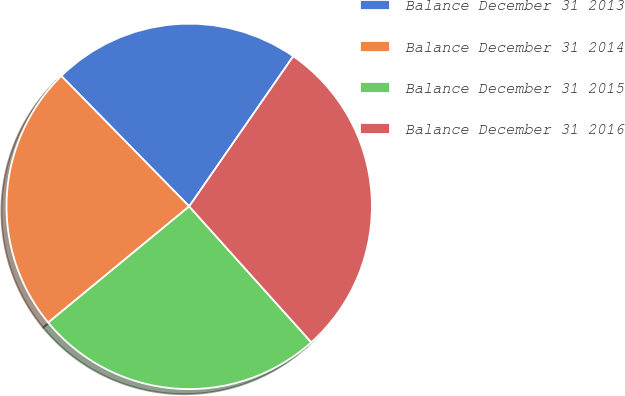<chart> <loc_0><loc_0><loc_500><loc_500><pie_chart><fcel>Balance December 31 2013<fcel>Balance December 31 2014<fcel>Balance December 31 2015<fcel>Balance December 31 2016<nl><fcel>21.99%<fcel>23.63%<fcel>25.68%<fcel>28.71%<nl></chart> 